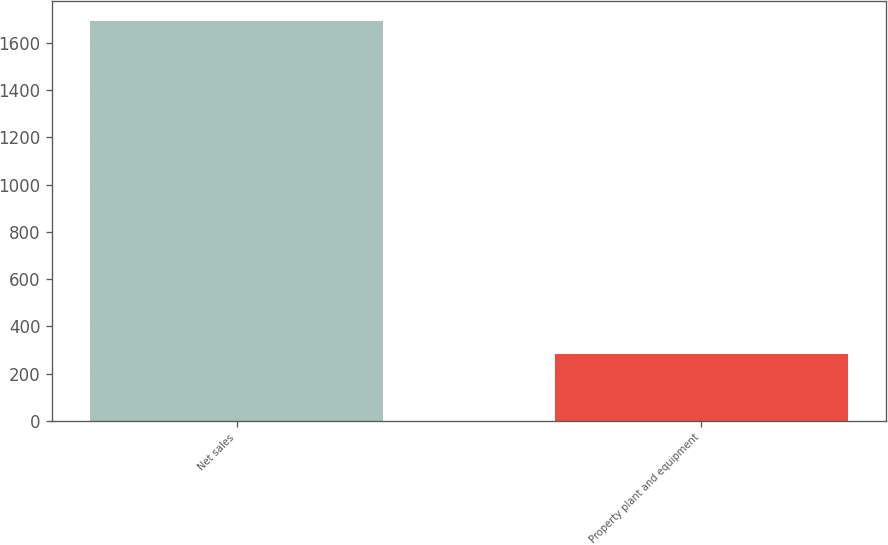<chart> <loc_0><loc_0><loc_500><loc_500><bar_chart><fcel>Net sales<fcel>Property plant and equipment<nl><fcel>1692.1<fcel>280.7<nl></chart> 